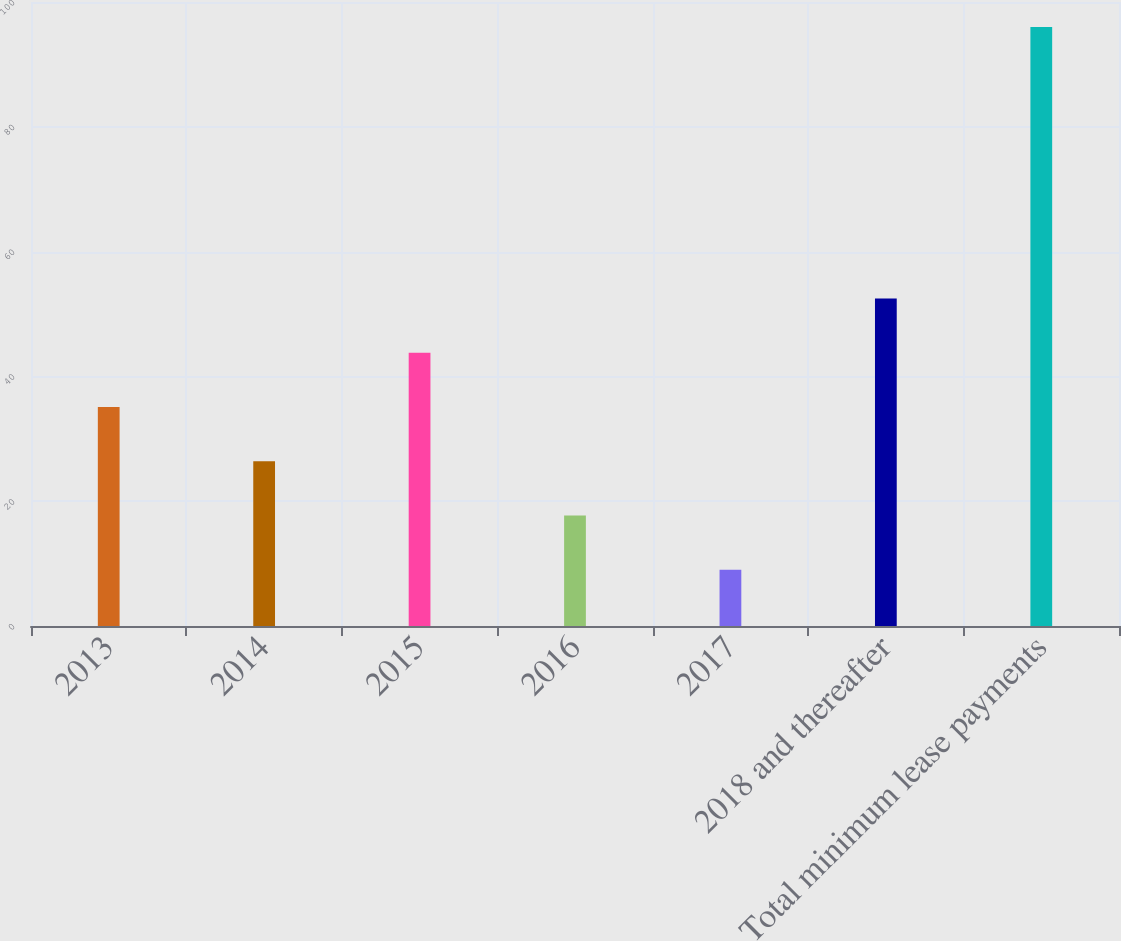<chart> <loc_0><loc_0><loc_500><loc_500><bar_chart><fcel>2013<fcel>2014<fcel>2015<fcel>2016<fcel>2017<fcel>2018 and thereafter<fcel>Total minimum lease payments<nl><fcel>35.1<fcel>26.4<fcel>43.8<fcel>17.7<fcel>9<fcel>52.5<fcel>96<nl></chart> 